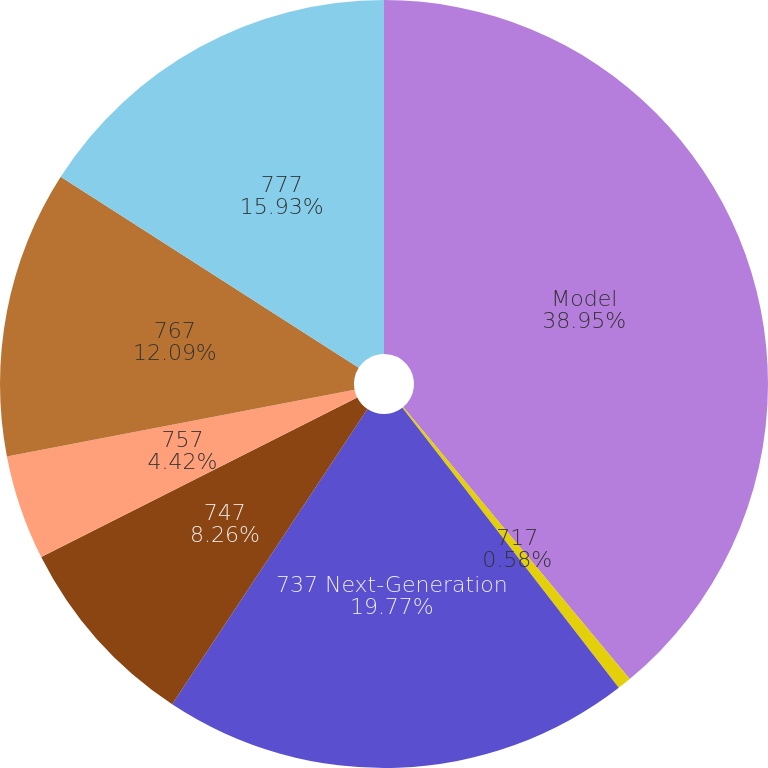Convert chart to OTSL. <chart><loc_0><loc_0><loc_500><loc_500><pie_chart><fcel>Model<fcel>717<fcel>737 Next-Generation<fcel>747<fcel>757<fcel>767<fcel>777<nl><fcel>38.95%<fcel>0.58%<fcel>19.77%<fcel>8.26%<fcel>4.42%<fcel>12.09%<fcel>15.93%<nl></chart> 